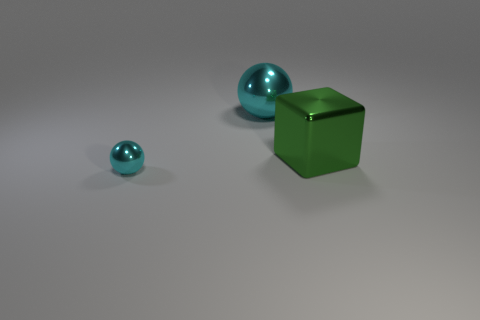Add 2 large green matte balls. How many objects exist? 5 Subtract all balls. How many objects are left? 1 Add 3 shiny balls. How many shiny balls are left? 5 Add 3 tiny metallic things. How many tiny metallic things exist? 4 Subtract 0 yellow blocks. How many objects are left? 3 Subtract all small purple rubber cylinders. Subtract all cyan spheres. How many objects are left? 1 